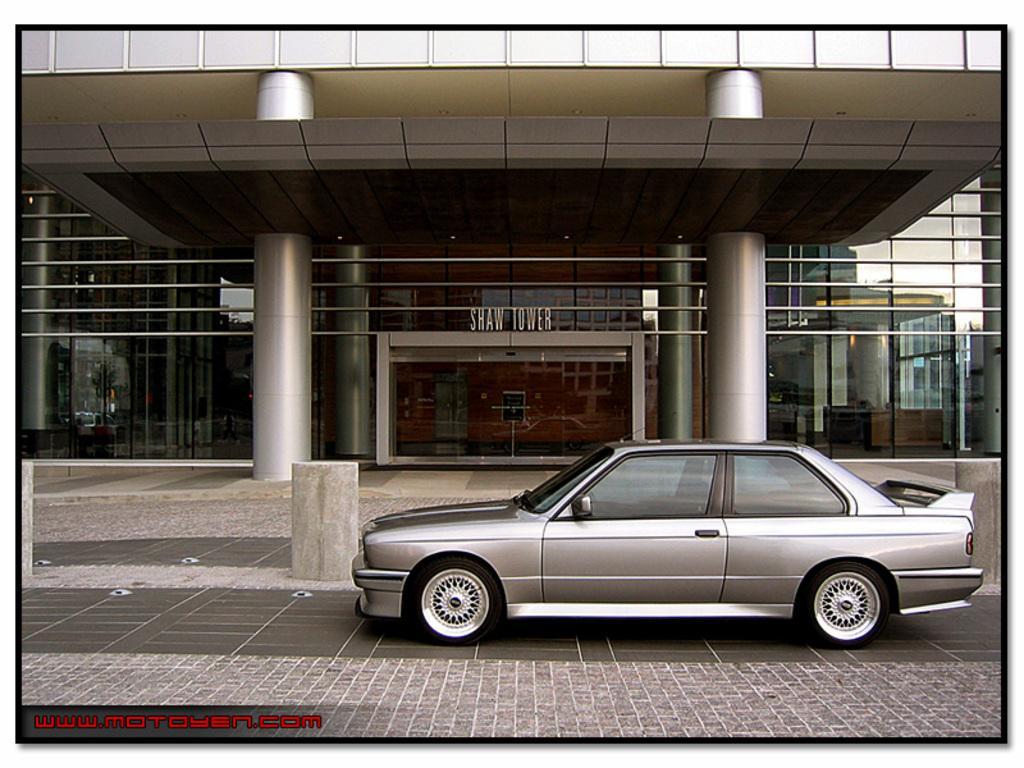Could you give a brief overview of what you see in this image? On the right side there is a vehicle on the road. In the background there is a building,glass doors,pillars,name board and through glass doors we can see objects and on the right side on the glass doors we can see reflection of a building and sky. 